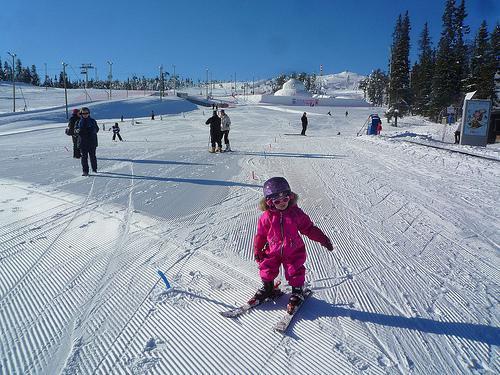How many people are wearing pink here?
Give a very brief answer. 1. How many people are wearing orange?
Give a very brief answer. 0. 